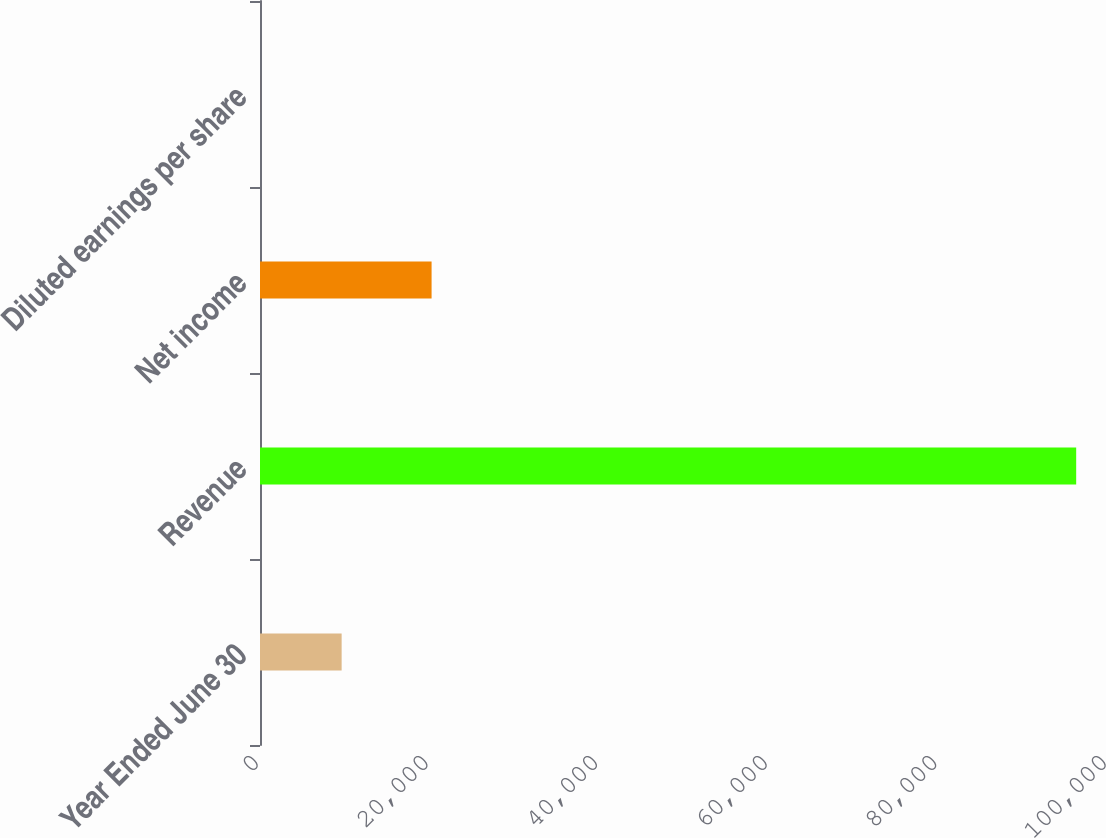Convert chart. <chart><loc_0><loc_0><loc_500><loc_500><bar_chart><fcel>Year Ended June 30<fcel>Revenue<fcel>Net income<fcel>Diluted earnings per share<nl><fcel>9626.97<fcel>96248<fcel>20234<fcel>2.41<nl></chart> 